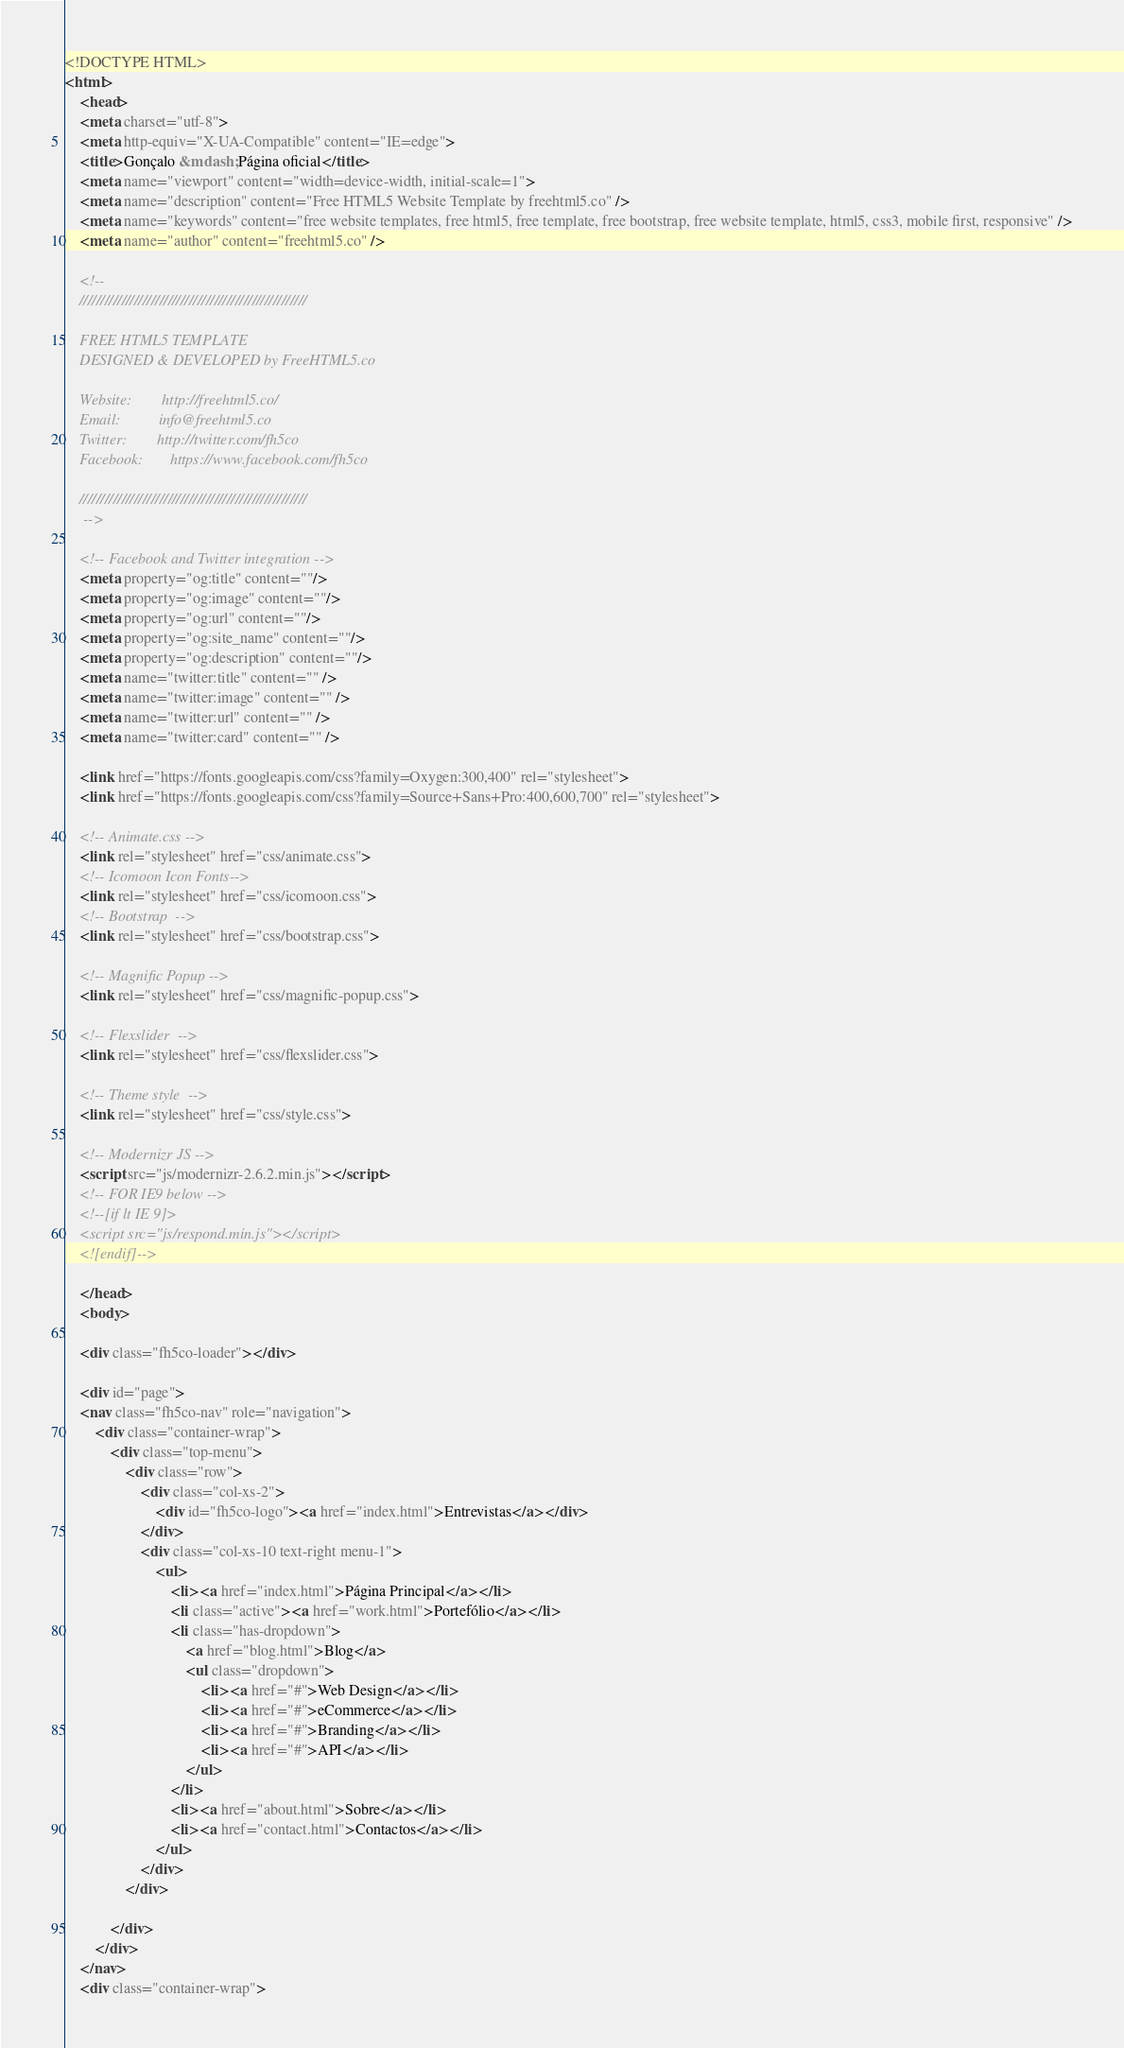Convert code to text. <code><loc_0><loc_0><loc_500><loc_500><_HTML_><!DOCTYPE HTML>
<html>
	<head>
	<meta charset="utf-8">
	<meta http-equiv="X-UA-Compatible" content="IE=edge">
	<title>Gonçalo &mdash; Página oficial</title>
	<meta name="viewport" content="width=device-width, initial-scale=1">
	<meta name="description" content="Free HTML5 Website Template by freehtml5.co" />
	<meta name="keywords" content="free website templates, free html5, free template, free bootstrap, free website template, html5, css3, mobile first, responsive" />
	<meta name="author" content="freehtml5.co" />

	<!--
	//////////////////////////////////////////////////////

	FREE HTML5 TEMPLATE
	DESIGNED & DEVELOPED by FreeHTML5.co

	Website: 		http://freehtml5.co/
	Email: 			info@freehtml5.co
	Twitter: 		http://twitter.com/fh5co
	Facebook: 		https://www.facebook.com/fh5co

	//////////////////////////////////////////////////////
	 -->

  	<!-- Facebook and Twitter integration -->
	<meta property="og:title" content=""/>
	<meta property="og:image" content=""/>
	<meta property="og:url" content=""/>
	<meta property="og:site_name" content=""/>
	<meta property="og:description" content=""/>
	<meta name="twitter:title" content="" />
	<meta name="twitter:image" content="" />
	<meta name="twitter:url" content="" />
	<meta name="twitter:card" content="" />

	<link href="https://fonts.googleapis.com/css?family=Oxygen:300,400" rel="stylesheet">
	<link href="https://fonts.googleapis.com/css?family=Source+Sans+Pro:400,600,700" rel="stylesheet">

	<!-- Animate.css -->
	<link rel="stylesheet" href="css/animate.css">
	<!-- Icomoon Icon Fonts-->
	<link rel="stylesheet" href="css/icomoon.css">
	<!-- Bootstrap  -->
	<link rel="stylesheet" href="css/bootstrap.css">

	<!-- Magnific Popup -->
	<link rel="stylesheet" href="css/magnific-popup.css">

	<!-- Flexslider  -->
	<link rel="stylesheet" href="css/flexslider.css">

	<!-- Theme style  -->
	<link rel="stylesheet" href="css/style.css">

	<!-- Modernizr JS -->
	<script src="js/modernizr-2.6.2.min.js"></script>
	<!-- FOR IE9 below -->
	<!--[if lt IE 9]>
	<script src="js/respond.min.js"></script>
	<![endif]-->

	</head>
	<body>

	<div class="fh5co-loader"></div>

	<div id="page">
	<nav class="fh5co-nav" role="navigation">
		<div class="container-wrap">
			<div class="top-menu">
				<div class="row">
					<div class="col-xs-2">
						<div id="fh5co-logo"><a href="index.html">Entrevistas</a></div>
					</div>
					<div class="col-xs-10 text-right menu-1">
						<ul>
							<li><a href="index.html">Página Principal</a></li>
							<li class="active"><a href="work.html">Portefólio</a></li>
							<li class="has-dropdown">
								<a href="blog.html">Blog</a>
								<ul class="dropdown">
									<li><a href="#">Web Design</a></li>
									<li><a href="#">eCommerce</a></li>
									<li><a href="#">Branding</a></li>
									<li><a href="#">API</a></li>
								</ul>
							</li>
							<li><a href="about.html">Sobre</a></li>
							<li><a href="contact.html">Contactos</a></li>
						</ul>
					</div>
				</div>

			</div>
		</div>
	</nav>
	<div class="container-wrap"></code> 